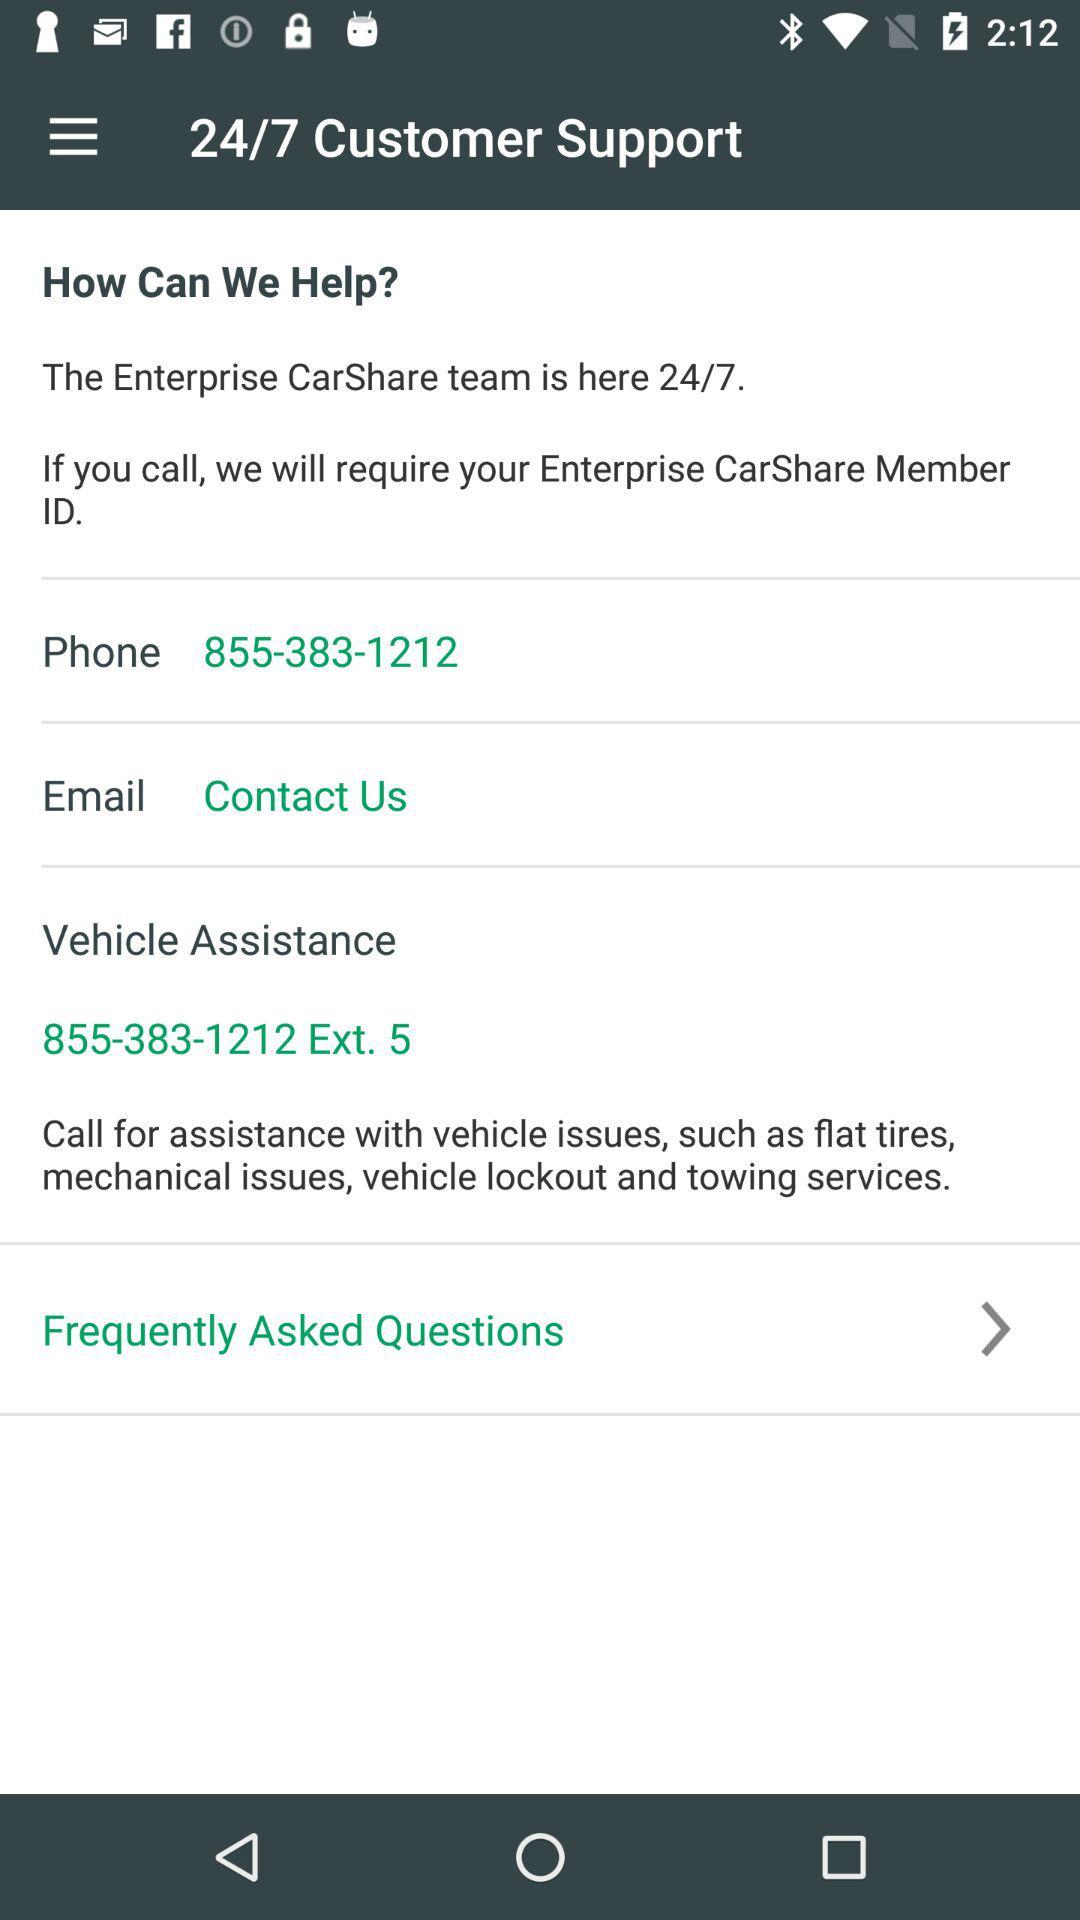What is the phone number? The phone number is 855-383-1212. 